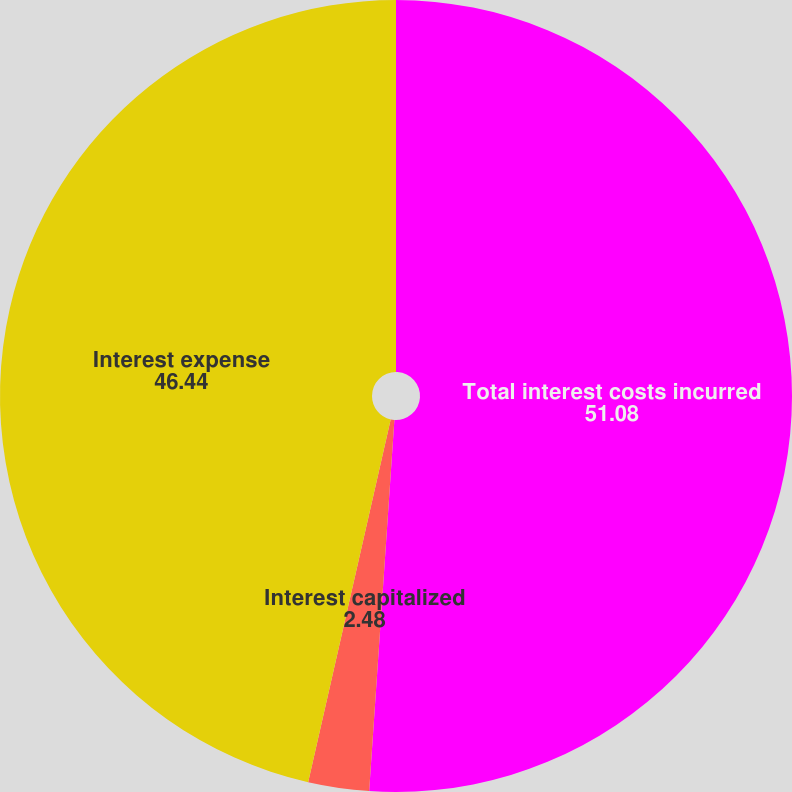<chart> <loc_0><loc_0><loc_500><loc_500><pie_chart><fcel>Total interest costs incurred<fcel>Interest capitalized<fcel>Interest expense<nl><fcel>51.08%<fcel>2.48%<fcel>46.44%<nl></chart> 